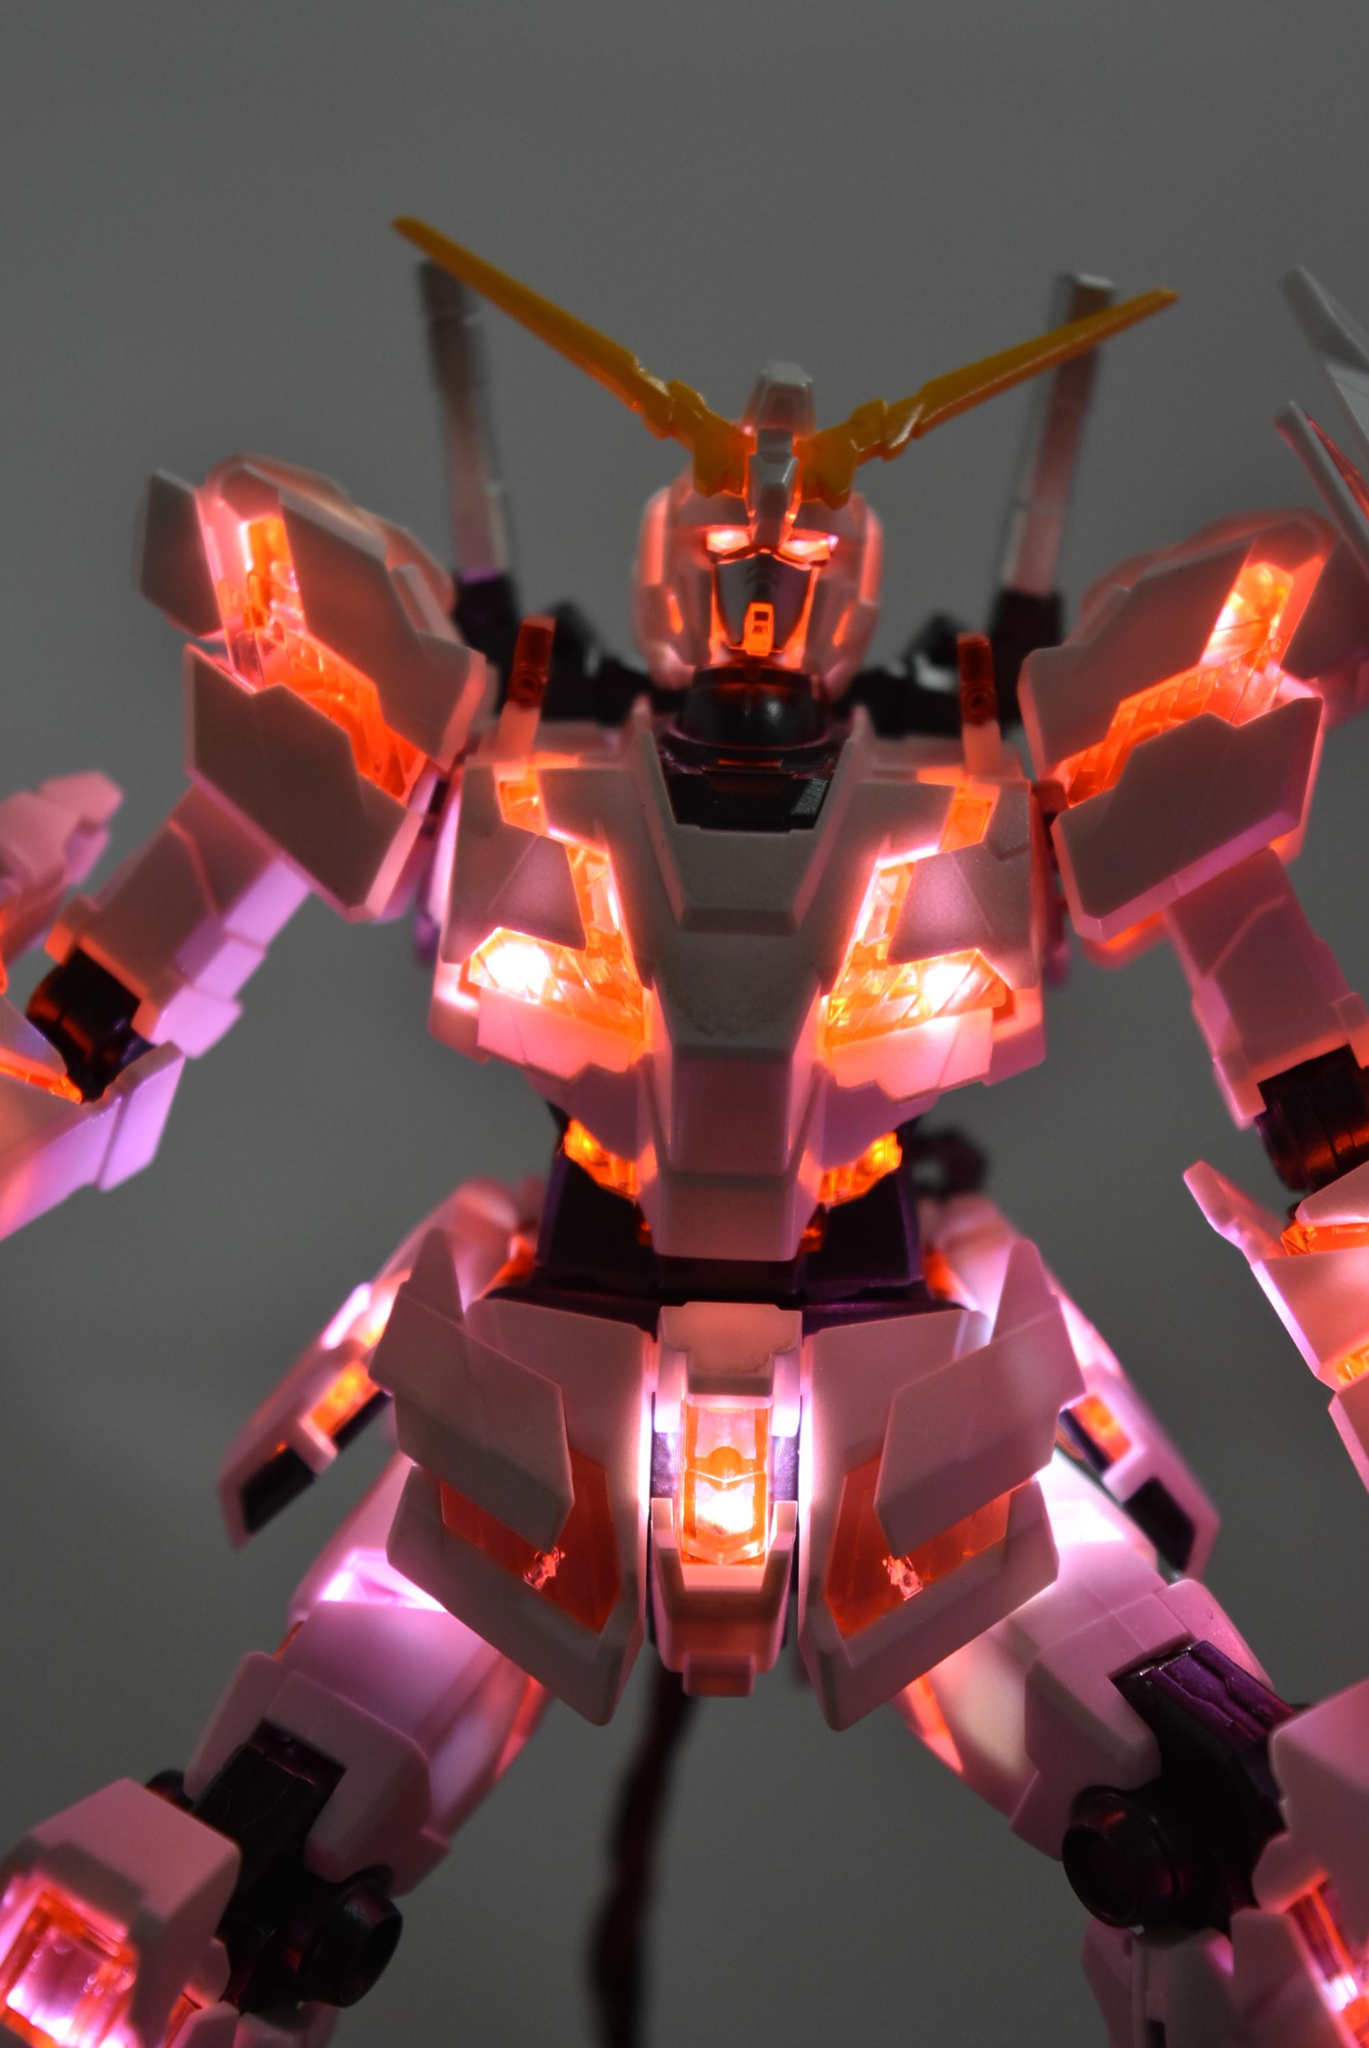What is the main object in the image? There is a toy in the image. Can you describe the colors of the toy? The toy has white and orange colors. Can you tell me how many snakes are resting on the toy in the image? There are no snakes present in the image, and therefore no such activity can be observed. 